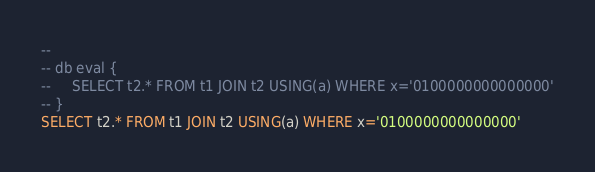<code> <loc_0><loc_0><loc_500><loc_500><_SQL_>-- 
-- db eval {
--     SELECT t2.* FROM t1 JOIN t2 USING(a) WHERE x='0100000000000000'
-- }
SELECT t2.* FROM t1 JOIN t2 USING(a) WHERE x='0100000000000000'</code> 